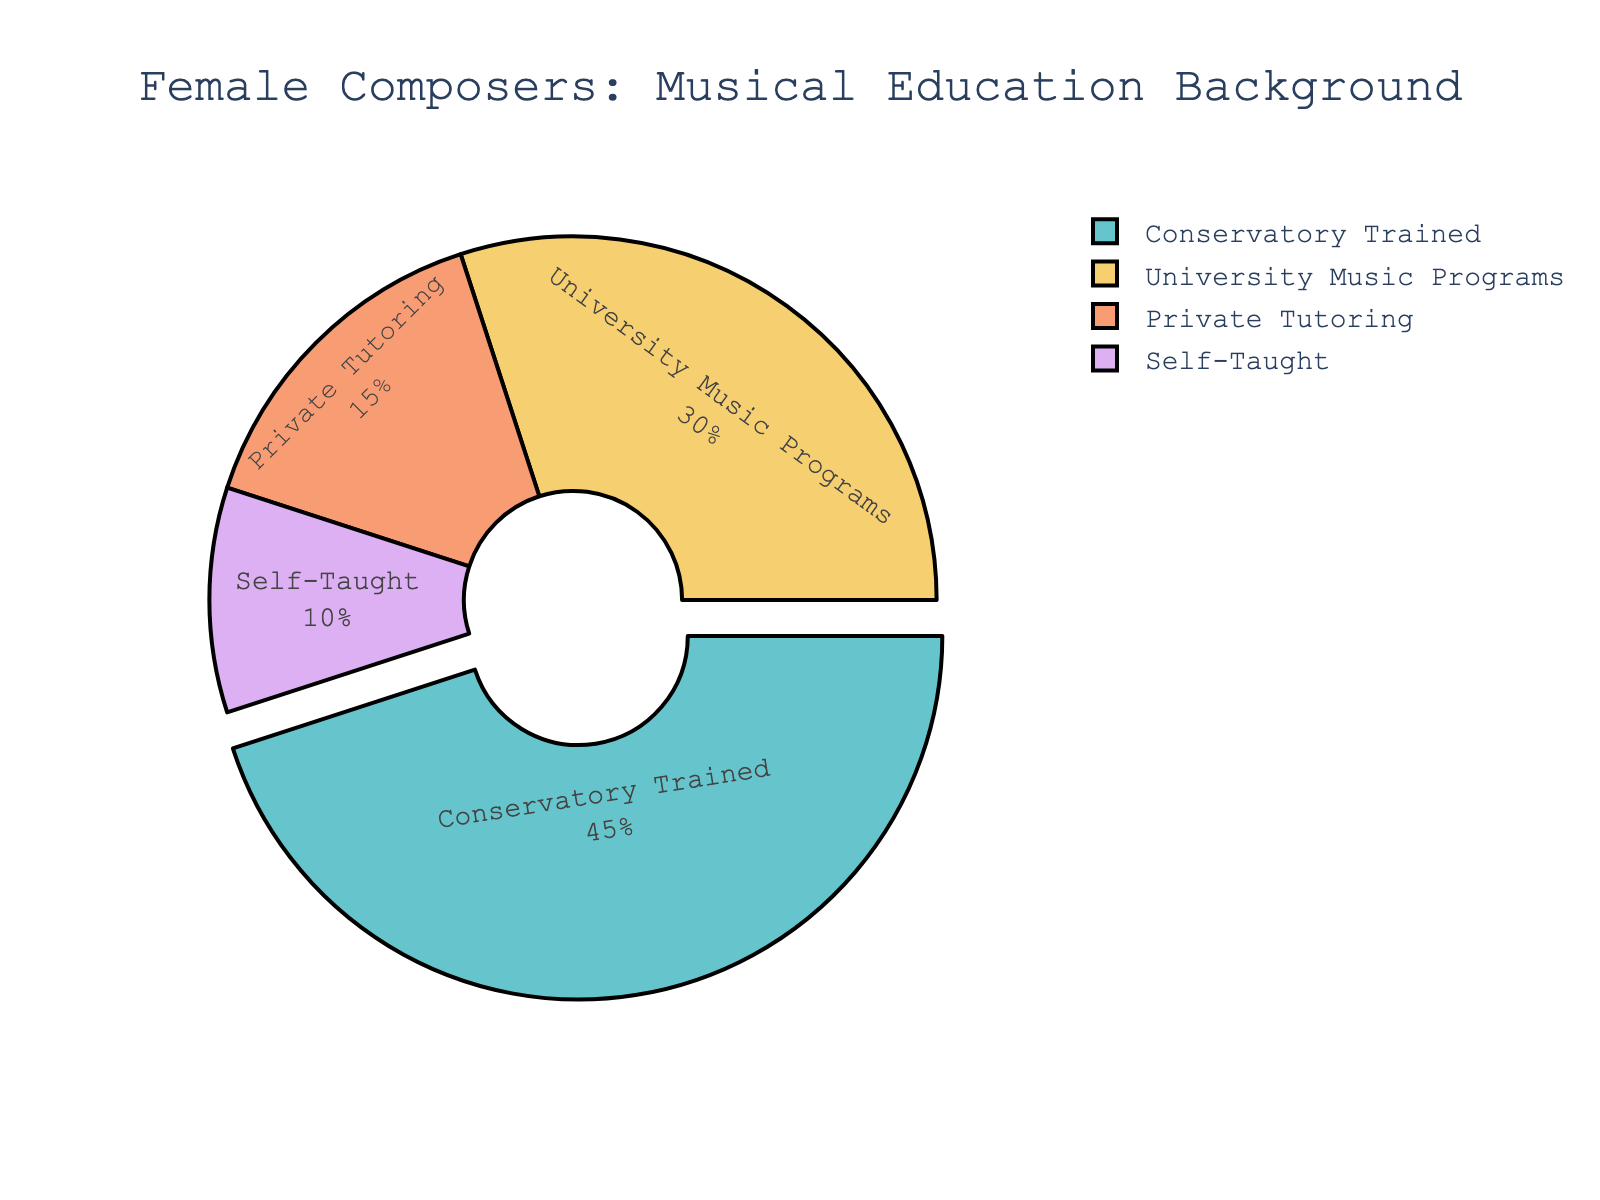What percentage of female composers have received formal education (Conservatory Trained and University Music Programs combined)? To find the combined percentage of female composers who received formal education, add the percentages of "Conservatory Trained" (45%) and "University Music Programs" (30%): 45% + 30% = 75%.
Answer: 75% Which education type has the highest proportion of female composers? By looking at the pie chart, "Conservatory Trained" has the largest section, representing 45% of the total.
Answer: Conservatory Trained What is the difference in percentage between female composers who received private tutoring and those who are self-taught? Subtract the percentage of "Self-Taught" (10%) from "Private Tutoring" (15%): 15% - 10% = 5%.
Answer: 5% What is the total percentage of female composers who received non-formal education (Private Tutoring and Self-Taught)? Add the percentages of "Private Tutoring" (15%) and "Self-Taught" (10%): 15% + 10% = 25%.
Answer: 25% Between "University Music Programs" and "Self-Taught" categories, which one has a higher percentage and by how much? "University Music Programs" has 30%, and "Self-Taught" has 10%. Subtract the percentage of "Self-Taught" from "University Music Programs": 30% - 10% = 20%.
Answer: University Music Programs by 20% What is the ratio of female composers with conservatory training to those who are self-taught? The percentage of "Conservatory Trained" composers is 45%, and for "Self-Taught" it is 10%. The ratio is 45:10, which simplifies to 4.5:1.
Answer: 4.5:1 If the pie chart were visualized as a bar chart, which bar would be the second highest? According to the given values, "University Music Programs" is the second highest at 30%.
Answer: University Music Programs Which education category accounts for the least percentage of female composers? The smallest section of the pie chart represents "Self-Taught" at 10%.
Answer: Self-Taught 